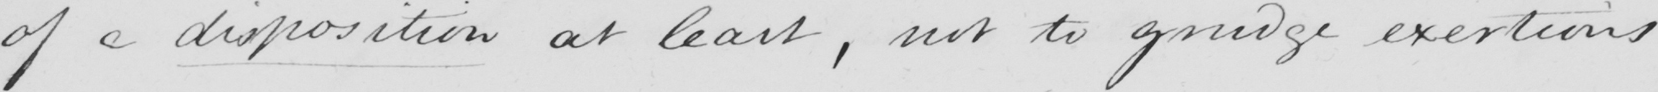Can you read and transcribe this handwriting? of a disposition at least , not to grudge exertions 